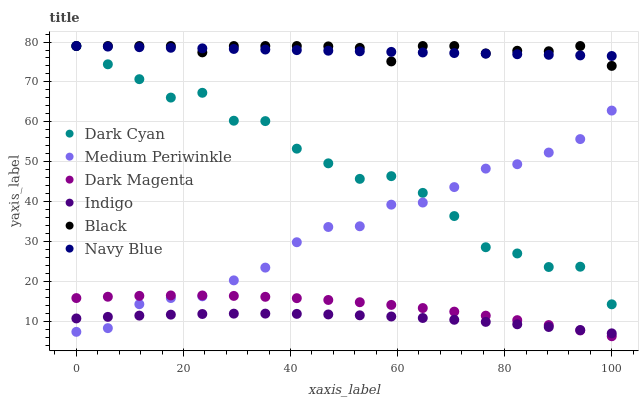Does Indigo have the minimum area under the curve?
Answer yes or no. Yes. Does Black have the maximum area under the curve?
Answer yes or no. Yes. Does Dark Magenta have the minimum area under the curve?
Answer yes or no. No. Does Dark Magenta have the maximum area under the curve?
Answer yes or no. No. Is Navy Blue the smoothest?
Answer yes or no. Yes. Is Dark Cyan the roughest?
Answer yes or no. Yes. Is Dark Magenta the smoothest?
Answer yes or no. No. Is Dark Magenta the roughest?
Answer yes or no. No. Does Dark Magenta have the lowest value?
Answer yes or no. Yes. Does Navy Blue have the lowest value?
Answer yes or no. No. Does Dark Cyan have the highest value?
Answer yes or no. Yes. Does Dark Magenta have the highest value?
Answer yes or no. No. Is Indigo less than Black?
Answer yes or no. Yes. Is Navy Blue greater than Dark Magenta?
Answer yes or no. Yes. Does Black intersect Navy Blue?
Answer yes or no. Yes. Is Black less than Navy Blue?
Answer yes or no. No. Is Black greater than Navy Blue?
Answer yes or no. No. Does Indigo intersect Black?
Answer yes or no. No. 